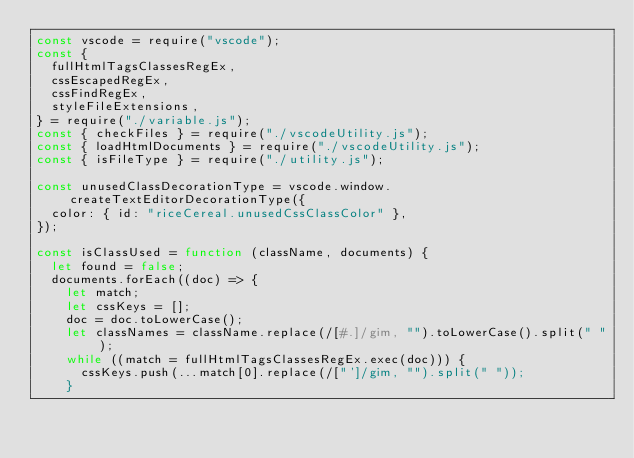<code> <loc_0><loc_0><loc_500><loc_500><_JavaScript_>const vscode = require("vscode");
const {
  fullHtmlTagsClassesRegEx,
  cssEscapedRegEx,
  cssFindRegEx,
  styleFileExtensions,
} = require("./variable.js");
const { checkFiles } = require("./vscodeUtility.js");
const { loadHtmlDocuments } = require("./vscodeUtility.js");
const { isFileType } = require("./utility.js");

const unusedClassDecorationType = vscode.window.createTextEditorDecorationType({
  color: { id: "riceCereal.unusedCssClassColor" },
});

const isClassUsed = function (className, documents) {
  let found = false;
  documents.forEach((doc) => {
    let match;
    let cssKeys = [];
    doc = doc.toLowerCase();
    let classNames = className.replace(/[#.]/gim, "").toLowerCase().split(" ");
    while ((match = fullHtmlTagsClassesRegEx.exec(doc))) {
      cssKeys.push(...match[0].replace(/["']/gim, "").split(" "));
    }</code> 